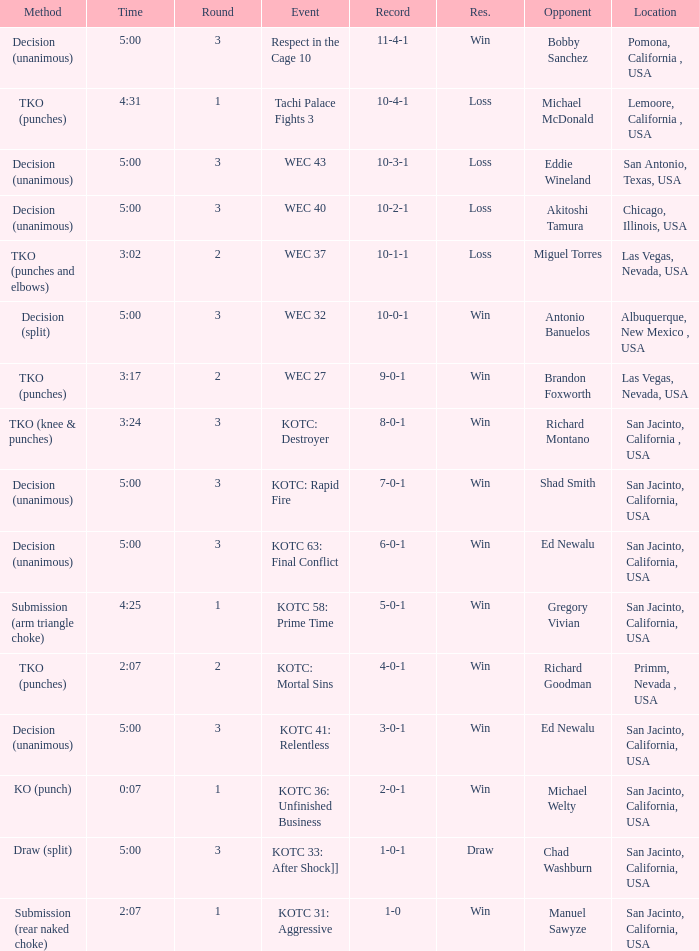What location did the event kotc: mortal sins take place? Primm, Nevada , USA. 